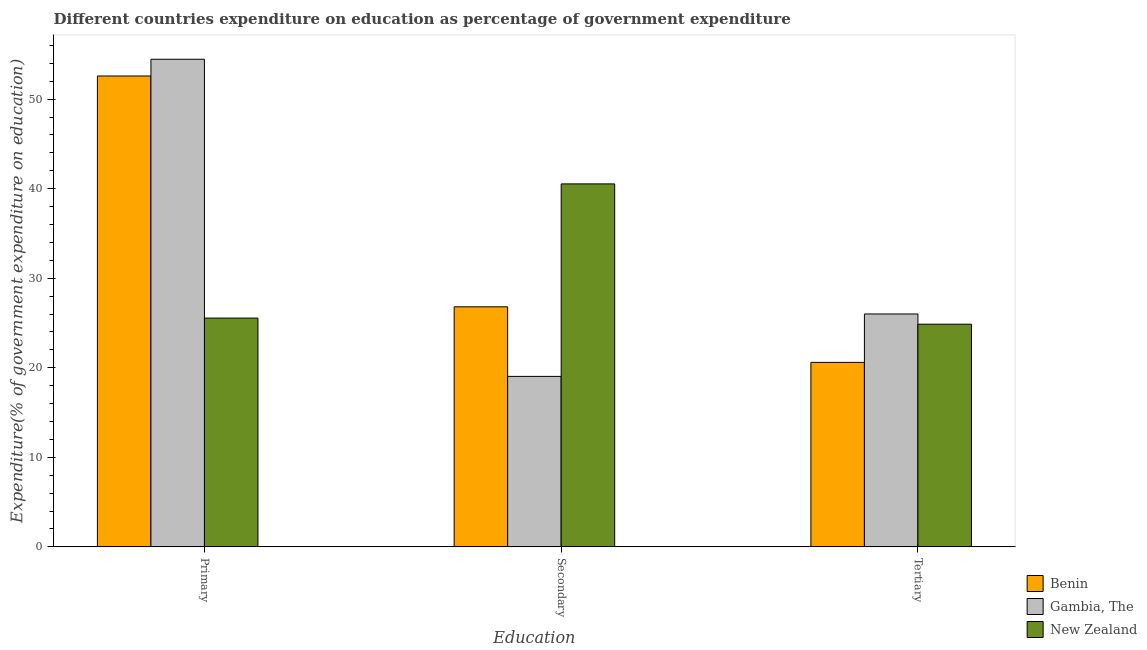How many groups of bars are there?
Keep it short and to the point. 3. Are the number of bars per tick equal to the number of legend labels?
Give a very brief answer. Yes. Are the number of bars on each tick of the X-axis equal?
Keep it short and to the point. Yes. How many bars are there on the 2nd tick from the left?
Provide a short and direct response. 3. What is the label of the 2nd group of bars from the left?
Make the answer very short. Secondary. What is the expenditure on primary education in Gambia, The?
Provide a short and direct response. 54.46. Across all countries, what is the maximum expenditure on tertiary education?
Your answer should be very brief. 26.01. Across all countries, what is the minimum expenditure on primary education?
Offer a terse response. 25.55. In which country was the expenditure on primary education maximum?
Give a very brief answer. Gambia, The. In which country was the expenditure on secondary education minimum?
Provide a succinct answer. Gambia, The. What is the total expenditure on primary education in the graph?
Provide a succinct answer. 132.6. What is the difference between the expenditure on primary education in New Zealand and that in Gambia, The?
Provide a succinct answer. -28.91. What is the difference between the expenditure on primary education in New Zealand and the expenditure on secondary education in Gambia, The?
Ensure brevity in your answer.  6.51. What is the average expenditure on secondary education per country?
Keep it short and to the point. 28.79. What is the difference between the expenditure on primary education and expenditure on tertiary education in New Zealand?
Your answer should be compact. 0.68. In how many countries, is the expenditure on tertiary education greater than 12 %?
Ensure brevity in your answer.  3. What is the ratio of the expenditure on primary education in New Zealand to that in Benin?
Provide a succinct answer. 0.49. Is the expenditure on secondary education in New Zealand less than that in Benin?
Provide a short and direct response. No. What is the difference between the highest and the second highest expenditure on secondary education?
Provide a succinct answer. 13.73. What is the difference between the highest and the lowest expenditure on tertiary education?
Your response must be concise. 5.41. In how many countries, is the expenditure on primary education greater than the average expenditure on primary education taken over all countries?
Your response must be concise. 2. Is the sum of the expenditure on secondary education in New Zealand and Gambia, The greater than the maximum expenditure on tertiary education across all countries?
Your answer should be very brief. Yes. What does the 1st bar from the left in Tertiary represents?
Provide a succinct answer. Benin. What does the 1st bar from the right in Tertiary represents?
Offer a very short reply. New Zealand. Is it the case that in every country, the sum of the expenditure on primary education and expenditure on secondary education is greater than the expenditure on tertiary education?
Provide a short and direct response. Yes. Are all the bars in the graph horizontal?
Ensure brevity in your answer.  No. How many countries are there in the graph?
Provide a succinct answer. 3. Are the values on the major ticks of Y-axis written in scientific E-notation?
Make the answer very short. No. Does the graph contain grids?
Ensure brevity in your answer.  No. Where does the legend appear in the graph?
Ensure brevity in your answer.  Bottom right. How are the legend labels stacked?
Your answer should be compact. Vertical. What is the title of the graph?
Offer a terse response. Different countries expenditure on education as percentage of government expenditure. What is the label or title of the X-axis?
Your answer should be compact. Education. What is the label or title of the Y-axis?
Make the answer very short. Expenditure(% of government expenditure on education). What is the Expenditure(% of government expenditure on education) of Benin in Primary?
Your answer should be very brief. 52.59. What is the Expenditure(% of government expenditure on education) of Gambia, The in Primary?
Ensure brevity in your answer.  54.46. What is the Expenditure(% of government expenditure on education) of New Zealand in Primary?
Your answer should be very brief. 25.55. What is the Expenditure(% of government expenditure on education) in Benin in Secondary?
Provide a short and direct response. 26.81. What is the Expenditure(% of government expenditure on education) in Gambia, The in Secondary?
Offer a terse response. 19.04. What is the Expenditure(% of government expenditure on education) of New Zealand in Secondary?
Offer a terse response. 40.54. What is the Expenditure(% of government expenditure on education) of Benin in Tertiary?
Offer a terse response. 20.6. What is the Expenditure(% of government expenditure on education) of Gambia, The in Tertiary?
Ensure brevity in your answer.  26.01. What is the Expenditure(% of government expenditure on education) in New Zealand in Tertiary?
Give a very brief answer. 24.87. Across all Education, what is the maximum Expenditure(% of government expenditure on education) in Benin?
Your answer should be very brief. 52.59. Across all Education, what is the maximum Expenditure(% of government expenditure on education) of Gambia, The?
Make the answer very short. 54.46. Across all Education, what is the maximum Expenditure(% of government expenditure on education) in New Zealand?
Ensure brevity in your answer.  40.54. Across all Education, what is the minimum Expenditure(% of government expenditure on education) in Benin?
Provide a succinct answer. 20.6. Across all Education, what is the minimum Expenditure(% of government expenditure on education) in Gambia, The?
Offer a terse response. 19.04. Across all Education, what is the minimum Expenditure(% of government expenditure on education) of New Zealand?
Offer a very short reply. 24.87. What is the total Expenditure(% of government expenditure on education) of Gambia, The in the graph?
Make the answer very short. 99.5. What is the total Expenditure(% of government expenditure on education) in New Zealand in the graph?
Your response must be concise. 90.95. What is the difference between the Expenditure(% of government expenditure on education) of Benin in Primary and that in Secondary?
Keep it short and to the point. 25.78. What is the difference between the Expenditure(% of government expenditure on education) of Gambia, The in Primary and that in Secondary?
Provide a succinct answer. 35.42. What is the difference between the Expenditure(% of government expenditure on education) in New Zealand in Primary and that in Secondary?
Your answer should be compact. -14.99. What is the difference between the Expenditure(% of government expenditure on education) of Benin in Primary and that in Tertiary?
Ensure brevity in your answer.  31.99. What is the difference between the Expenditure(% of government expenditure on education) of Gambia, The in Primary and that in Tertiary?
Your answer should be compact. 28.45. What is the difference between the Expenditure(% of government expenditure on education) of New Zealand in Primary and that in Tertiary?
Offer a terse response. 0.68. What is the difference between the Expenditure(% of government expenditure on education) in Benin in Secondary and that in Tertiary?
Your answer should be compact. 6.21. What is the difference between the Expenditure(% of government expenditure on education) in Gambia, The in Secondary and that in Tertiary?
Offer a very short reply. -6.97. What is the difference between the Expenditure(% of government expenditure on education) in New Zealand in Secondary and that in Tertiary?
Provide a short and direct response. 15.67. What is the difference between the Expenditure(% of government expenditure on education) in Benin in Primary and the Expenditure(% of government expenditure on education) in Gambia, The in Secondary?
Make the answer very short. 33.55. What is the difference between the Expenditure(% of government expenditure on education) in Benin in Primary and the Expenditure(% of government expenditure on education) in New Zealand in Secondary?
Keep it short and to the point. 12.05. What is the difference between the Expenditure(% of government expenditure on education) of Gambia, The in Primary and the Expenditure(% of government expenditure on education) of New Zealand in Secondary?
Your response must be concise. 13.92. What is the difference between the Expenditure(% of government expenditure on education) of Benin in Primary and the Expenditure(% of government expenditure on education) of Gambia, The in Tertiary?
Ensure brevity in your answer.  26.58. What is the difference between the Expenditure(% of government expenditure on education) of Benin in Primary and the Expenditure(% of government expenditure on education) of New Zealand in Tertiary?
Keep it short and to the point. 27.72. What is the difference between the Expenditure(% of government expenditure on education) of Gambia, The in Primary and the Expenditure(% of government expenditure on education) of New Zealand in Tertiary?
Make the answer very short. 29.59. What is the difference between the Expenditure(% of government expenditure on education) in Benin in Secondary and the Expenditure(% of government expenditure on education) in Gambia, The in Tertiary?
Give a very brief answer. 0.8. What is the difference between the Expenditure(% of government expenditure on education) of Benin in Secondary and the Expenditure(% of government expenditure on education) of New Zealand in Tertiary?
Your response must be concise. 1.94. What is the difference between the Expenditure(% of government expenditure on education) in Gambia, The in Secondary and the Expenditure(% of government expenditure on education) in New Zealand in Tertiary?
Your answer should be compact. -5.83. What is the average Expenditure(% of government expenditure on education) of Benin per Education?
Offer a very short reply. 33.33. What is the average Expenditure(% of government expenditure on education) of Gambia, The per Education?
Your response must be concise. 33.17. What is the average Expenditure(% of government expenditure on education) of New Zealand per Education?
Provide a succinct answer. 30.32. What is the difference between the Expenditure(% of government expenditure on education) in Benin and Expenditure(% of government expenditure on education) in Gambia, The in Primary?
Give a very brief answer. -1.87. What is the difference between the Expenditure(% of government expenditure on education) of Benin and Expenditure(% of government expenditure on education) of New Zealand in Primary?
Make the answer very short. 27.04. What is the difference between the Expenditure(% of government expenditure on education) in Gambia, The and Expenditure(% of government expenditure on education) in New Zealand in Primary?
Provide a short and direct response. 28.91. What is the difference between the Expenditure(% of government expenditure on education) in Benin and Expenditure(% of government expenditure on education) in Gambia, The in Secondary?
Give a very brief answer. 7.77. What is the difference between the Expenditure(% of government expenditure on education) in Benin and Expenditure(% of government expenditure on education) in New Zealand in Secondary?
Ensure brevity in your answer.  -13.73. What is the difference between the Expenditure(% of government expenditure on education) in Gambia, The and Expenditure(% of government expenditure on education) in New Zealand in Secondary?
Your response must be concise. -21.5. What is the difference between the Expenditure(% of government expenditure on education) in Benin and Expenditure(% of government expenditure on education) in Gambia, The in Tertiary?
Keep it short and to the point. -5.41. What is the difference between the Expenditure(% of government expenditure on education) in Benin and Expenditure(% of government expenditure on education) in New Zealand in Tertiary?
Keep it short and to the point. -4.27. What is the difference between the Expenditure(% of government expenditure on education) in Gambia, The and Expenditure(% of government expenditure on education) in New Zealand in Tertiary?
Keep it short and to the point. 1.14. What is the ratio of the Expenditure(% of government expenditure on education) in Benin in Primary to that in Secondary?
Offer a terse response. 1.96. What is the ratio of the Expenditure(% of government expenditure on education) in Gambia, The in Primary to that in Secondary?
Give a very brief answer. 2.86. What is the ratio of the Expenditure(% of government expenditure on education) in New Zealand in Primary to that in Secondary?
Your answer should be compact. 0.63. What is the ratio of the Expenditure(% of government expenditure on education) in Benin in Primary to that in Tertiary?
Offer a very short reply. 2.55. What is the ratio of the Expenditure(% of government expenditure on education) of Gambia, The in Primary to that in Tertiary?
Your response must be concise. 2.09. What is the ratio of the Expenditure(% of government expenditure on education) in New Zealand in Primary to that in Tertiary?
Keep it short and to the point. 1.03. What is the ratio of the Expenditure(% of government expenditure on education) in Benin in Secondary to that in Tertiary?
Your answer should be very brief. 1.3. What is the ratio of the Expenditure(% of government expenditure on education) in Gambia, The in Secondary to that in Tertiary?
Offer a terse response. 0.73. What is the ratio of the Expenditure(% of government expenditure on education) in New Zealand in Secondary to that in Tertiary?
Ensure brevity in your answer.  1.63. What is the difference between the highest and the second highest Expenditure(% of government expenditure on education) in Benin?
Your answer should be compact. 25.78. What is the difference between the highest and the second highest Expenditure(% of government expenditure on education) of Gambia, The?
Give a very brief answer. 28.45. What is the difference between the highest and the second highest Expenditure(% of government expenditure on education) in New Zealand?
Offer a terse response. 14.99. What is the difference between the highest and the lowest Expenditure(% of government expenditure on education) in Benin?
Make the answer very short. 31.99. What is the difference between the highest and the lowest Expenditure(% of government expenditure on education) of Gambia, The?
Provide a succinct answer. 35.42. What is the difference between the highest and the lowest Expenditure(% of government expenditure on education) of New Zealand?
Give a very brief answer. 15.67. 